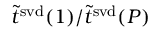<formula> <loc_0><loc_0><loc_500><loc_500>\tilde { t } ^ { s v d } ( 1 ) / \tilde { t } ^ { s v d } ( P )</formula> 